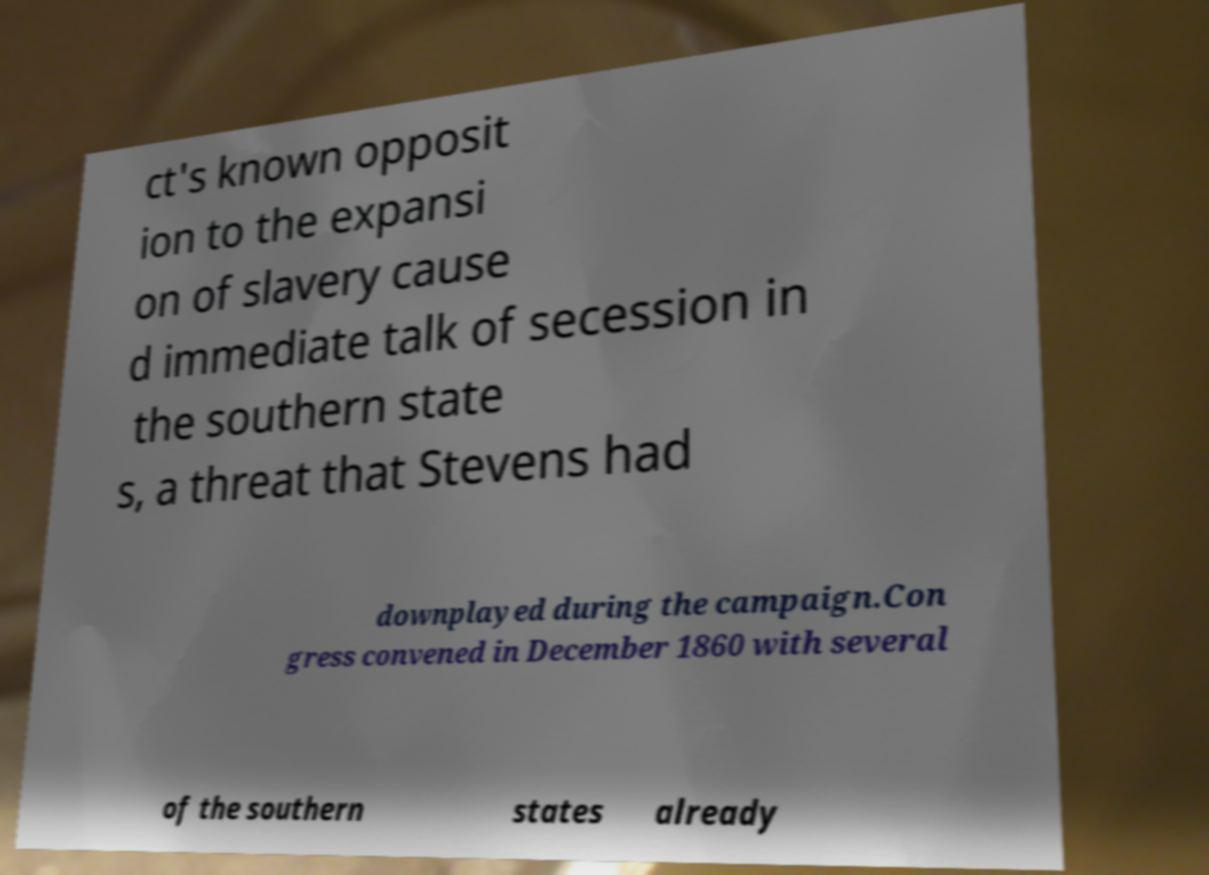Could you assist in decoding the text presented in this image and type it out clearly? ct's known opposit ion to the expansi on of slavery cause d immediate talk of secession in the southern state s, a threat that Stevens had downplayed during the campaign.Con gress convened in December 1860 with several of the southern states already 